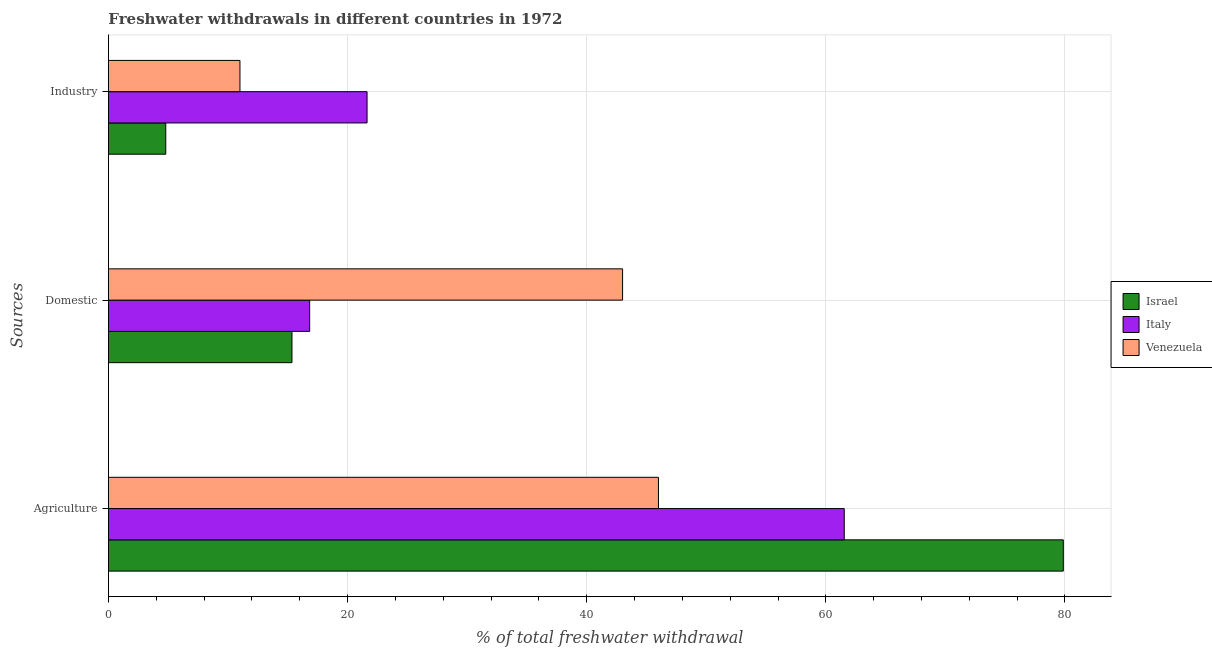How many different coloured bars are there?
Your answer should be very brief. 3. How many bars are there on the 1st tick from the top?
Make the answer very short. 3. What is the label of the 2nd group of bars from the top?
Keep it short and to the point. Domestic. What is the percentage of freshwater withdrawal for industry in Israel?
Provide a short and direct response. 4.79. Across all countries, what is the maximum percentage of freshwater withdrawal for agriculture?
Make the answer very short. 79.86. Across all countries, what is the minimum percentage of freshwater withdrawal for industry?
Keep it short and to the point. 4.79. In which country was the percentage of freshwater withdrawal for domestic purposes maximum?
Offer a very short reply. Venezuela. In which country was the percentage of freshwater withdrawal for domestic purposes minimum?
Offer a terse response. Israel. What is the total percentage of freshwater withdrawal for industry in the graph?
Make the answer very short. 37.42. What is the difference between the percentage of freshwater withdrawal for industry in Israel and that in Italy?
Keep it short and to the point. -16.84. What is the difference between the percentage of freshwater withdrawal for industry in Italy and the percentage of freshwater withdrawal for domestic purposes in Venezuela?
Provide a short and direct response. -21.37. What is the average percentage of freshwater withdrawal for industry per country?
Your answer should be compact. 12.47. What is the difference between the percentage of freshwater withdrawal for domestic purposes and percentage of freshwater withdrawal for agriculture in Italy?
Give a very brief answer. -44.71. What is the ratio of the percentage of freshwater withdrawal for agriculture in Israel to that in Italy?
Your response must be concise. 1.3. What is the difference between the highest and the second highest percentage of freshwater withdrawal for domestic purposes?
Your answer should be very brief. 26.17. What is the difference between the highest and the lowest percentage of freshwater withdrawal for industry?
Keep it short and to the point. 16.84. In how many countries, is the percentage of freshwater withdrawal for agriculture greater than the average percentage of freshwater withdrawal for agriculture taken over all countries?
Keep it short and to the point. 1. Is the sum of the percentage of freshwater withdrawal for agriculture in Venezuela and Israel greater than the maximum percentage of freshwater withdrawal for domestic purposes across all countries?
Keep it short and to the point. Yes. What does the 1st bar from the top in Domestic represents?
Your answer should be compact. Venezuela. What does the 1st bar from the bottom in Domestic represents?
Keep it short and to the point. Israel. How many countries are there in the graph?
Your answer should be very brief. 3. Are the values on the major ticks of X-axis written in scientific E-notation?
Keep it short and to the point. No. Does the graph contain any zero values?
Ensure brevity in your answer.  No. Does the graph contain grids?
Your answer should be compact. Yes. Where does the legend appear in the graph?
Give a very brief answer. Center right. How many legend labels are there?
Keep it short and to the point. 3. What is the title of the graph?
Ensure brevity in your answer.  Freshwater withdrawals in different countries in 1972. What is the label or title of the X-axis?
Ensure brevity in your answer.  % of total freshwater withdrawal. What is the label or title of the Y-axis?
Keep it short and to the point. Sources. What is the % of total freshwater withdrawal in Israel in Agriculture?
Provide a succinct answer. 79.86. What is the % of total freshwater withdrawal in Italy in Agriculture?
Keep it short and to the point. 61.54. What is the % of total freshwater withdrawal in Venezuela in Agriculture?
Provide a succinct answer. 46. What is the % of total freshwater withdrawal of Israel in Domestic?
Your answer should be very brief. 15.35. What is the % of total freshwater withdrawal of Italy in Domestic?
Give a very brief answer. 16.83. What is the % of total freshwater withdrawal of Israel in Industry?
Your answer should be very brief. 4.79. What is the % of total freshwater withdrawal in Italy in Industry?
Ensure brevity in your answer.  21.63. What is the % of total freshwater withdrawal of Venezuela in Industry?
Your response must be concise. 11. Across all Sources, what is the maximum % of total freshwater withdrawal of Israel?
Offer a terse response. 79.86. Across all Sources, what is the maximum % of total freshwater withdrawal in Italy?
Keep it short and to the point. 61.54. Across all Sources, what is the minimum % of total freshwater withdrawal in Israel?
Offer a terse response. 4.79. Across all Sources, what is the minimum % of total freshwater withdrawal of Italy?
Provide a short and direct response. 16.83. Across all Sources, what is the minimum % of total freshwater withdrawal of Venezuela?
Give a very brief answer. 11. What is the total % of total freshwater withdrawal of Israel in the graph?
Offer a very short reply. 100. What is the total % of total freshwater withdrawal of Italy in the graph?
Provide a succinct answer. 100. What is the total % of total freshwater withdrawal in Venezuela in the graph?
Provide a short and direct response. 100. What is the difference between the % of total freshwater withdrawal of Israel in Agriculture and that in Domestic?
Your response must be concise. 64.51. What is the difference between the % of total freshwater withdrawal of Italy in Agriculture and that in Domestic?
Make the answer very short. 44.71. What is the difference between the % of total freshwater withdrawal of Venezuela in Agriculture and that in Domestic?
Provide a short and direct response. 3. What is the difference between the % of total freshwater withdrawal in Israel in Agriculture and that in Industry?
Your answer should be very brief. 75.06. What is the difference between the % of total freshwater withdrawal in Italy in Agriculture and that in Industry?
Provide a succinct answer. 39.91. What is the difference between the % of total freshwater withdrawal of Venezuela in Agriculture and that in Industry?
Provide a short and direct response. 35. What is the difference between the % of total freshwater withdrawal of Israel in Domestic and that in Industry?
Your response must be concise. 10.55. What is the difference between the % of total freshwater withdrawal of Venezuela in Domestic and that in Industry?
Your answer should be very brief. 32. What is the difference between the % of total freshwater withdrawal in Israel in Agriculture and the % of total freshwater withdrawal in Italy in Domestic?
Give a very brief answer. 63.03. What is the difference between the % of total freshwater withdrawal of Israel in Agriculture and the % of total freshwater withdrawal of Venezuela in Domestic?
Keep it short and to the point. 36.86. What is the difference between the % of total freshwater withdrawal in Italy in Agriculture and the % of total freshwater withdrawal in Venezuela in Domestic?
Your response must be concise. 18.54. What is the difference between the % of total freshwater withdrawal of Israel in Agriculture and the % of total freshwater withdrawal of Italy in Industry?
Your response must be concise. 58.23. What is the difference between the % of total freshwater withdrawal of Israel in Agriculture and the % of total freshwater withdrawal of Venezuela in Industry?
Ensure brevity in your answer.  68.86. What is the difference between the % of total freshwater withdrawal in Italy in Agriculture and the % of total freshwater withdrawal in Venezuela in Industry?
Your answer should be compact. 50.54. What is the difference between the % of total freshwater withdrawal in Israel in Domestic and the % of total freshwater withdrawal in Italy in Industry?
Offer a very short reply. -6.28. What is the difference between the % of total freshwater withdrawal of Israel in Domestic and the % of total freshwater withdrawal of Venezuela in Industry?
Give a very brief answer. 4.35. What is the difference between the % of total freshwater withdrawal of Italy in Domestic and the % of total freshwater withdrawal of Venezuela in Industry?
Provide a succinct answer. 5.83. What is the average % of total freshwater withdrawal of Israel per Sources?
Your answer should be compact. 33.34. What is the average % of total freshwater withdrawal of Italy per Sources?
Give a very brief answer. 33.33. What is the average % of total freshwater withdrawal of Venezuela per Sources?
Offer a very short reply. 33.33. What is the difference between the % of total freshwater withdrawal of Israel and % of total freshwater withdrawal of Italy in Agriculture?
Offer a terse response. 18.32. What is the difference between the % of total freshwater withdrawal of Israel and % of total freshwater withdrawal of Venezuela in Agriculture?
Provide a succinct answer. 33.86. What is the difference between the % of total freshwater withdrawal in Italy and % of total freshwater withdrawal in Venezuela in Agriculture?
Offer a very short reply. 15.54. What is the difference between the % of total freshwater withdrawal in Israel and % of total freshwater withdrawal in Italy in Domestic?
Give a very brief answer. -1.48. What is the difference between the % of total freshwater withdrawal of Israel and % of total freshwater withdrawal of Venezuela in Domestic?
Provide a short and direct response. -27.65. What is the difference between the % of total freshwater withdrawal of Italy and % of total freshwater withdrawal of Venezuela in Domestic?
Your answer should be compact. -26.17. What is the difference between the % of total freshwater withdrawal in Israel and % of total freshwater withdrawal in Italy in Industry?
Ensure brevity in your answer.  -16.84. What is the difference between the % of total freshwater withdrawal in Israel and % of total freshwater withdrawal in Venezuela in Industry?
Your answer should be compact. -6.21. What is the difference between the % of total freshwater withdrawal in Italy and % of total freshwater withdrawal in Venezuela in Industry?
Keep it short and to the point. 10.63. What is the ratio of the % of total freshwater withdrawal in Israel in Agriculture to that in Domestic?
Keep it short and to the point. 5.2. What is the ratio of the % of total freshwater withdrawal of Italy in Agriculture to that in Domestic?
Your answer should be compact. 3.66. What is the ratio of the % of total freshwater withdrawal in Venezuela in Agriculture to that in Domestic?
Give a very brief answer. 1.07. What is the ratio of the % of total freshwater withdrawal in Israel in Agriculture to that in Industry?
Make the answer very short. 16.65. What is the ratio of the % of total freshwater withdrawal in Italy in Agriculture to that in Industry?
Keep it short and to the point. 2.85. What is the ratio of the % of total freshwater withdrawal of Venezuela in Agriculture to that in Industry?
Your answer should be very brief. 4.18. What is the ratio of the % of total freshwater withdrawal in Israel in Domestic to that in Industry?
Keep it short and to the point. 3.2. What is the ratio of the % of total freshwater withdrawal of Italy in Domestic to that in Industry?
Offer a terse response. 0.78. What is the ratio of the % of total freshwater withdrawal of Venezuela in Domestic to that in Industry?
Your answer should be compact. 3.91. What is the difference between the highest and the second highest % of total freshwater withdrawal in Israel?
Your response must be concise. 64.51. What is the difference between the highest and the second highest % of total freshwater withdrawal in Italy?
Keep it short and to the point. 39.91. What is the difference between the highest and the second highest % of total freshwater withdrawal in Venezuela?
Your answer should be very brief. 3. What is the difference between the highest and the lowest % of total freshwater withdrawal of Israel?
Ensure brevity in your answer.  75.06. What is the difference between the highest and the lowest % of total freshwater withdrawal of Italy?
Provide a succinct answer. 44.71. What is the difference between the highest and the lowest % of total freshwater withdrawal of Venezuela?
Offer a terse response. 35. 